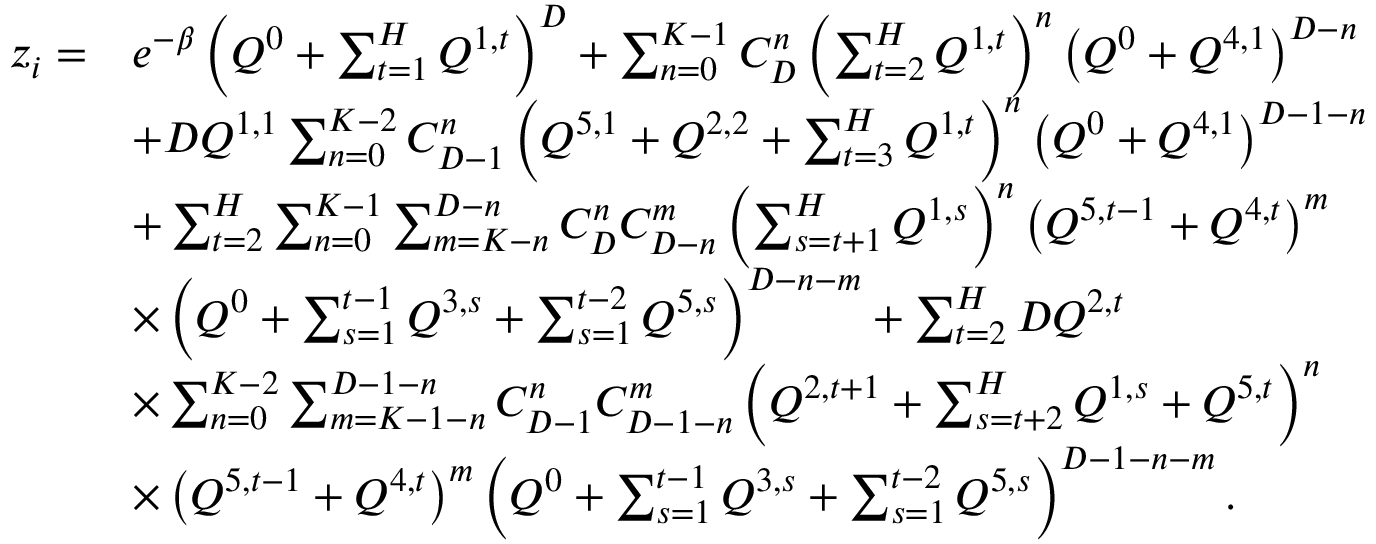<formula> <loc_0><loc_0><loc_500><loc_500>\begin{array} { r l } { z _ { i } = } & { e ^ { - \beta } \left ( Q ^ { 0 } + \sum _ { t = 1 } ^ { H } Q ^ { 1 , t } \right ) ^ { D } + \sum _ { n = 0 } ^ { K - 1 } C _ { D } ^ { n } \left ( \sum _ { t = 2 } ^ { H } Q ^ { 1 , t } \right ) ^ { n } \left ( Q ^ { 0 } + Q ^ { 4 , 1 } \right ) ^ { D - n } } \\ & { + D Q ^ { 1 , 1 } \sum _ { n = 0 } ^ { K - 2 } C _ { D - 1 } ^ { n } \left ( Q ^ { 5 , 1 } + Q ^ { 2 , 2 } + \sum _ { t = 3 } ^ { H } Q ^ { 1 , t } \right ) ^ { n } \left ( Q ^ { 0 } + Q ^ { 4 , 1 } \right ) ^ { D - 1 - n } } \\ & { + \sum _ { t = 2 } ^ { H } \sum _ { n = 0 } ^ { K - 1 } \sum _ { m = K - n } ^ { D - n } C _ { D } ^ { n } C _ { D - n } ^ { m } \left ( \sum _ { s = t + 1 } ^ { H } Q ^ { 1 , s } \right ) ^ { n } \left ( Q ^ { 5 , t - 1 } + Q ^ { 4 , t } \right ) ^ { m } } \\ & { \times \left ( Q ^ { 0 } + \sum _ { s = 1 } ^ { t - 1 } Q ^ { 3 , s } + \sum _ { s = 1 } ^ { t - 2 } Q ^ { 5 , s } \right ) ^ { D - n - m } + \sum _ { t = 2 } ^ { H } D Q ^ { 2 , t } } \\ & { \times \sum _ { n = 0 } ^ { K - 2 } \sum _ { m = K - 1 - n } ^ { D - 1 - n } C _ { D - 1 } ^ { n } C _ { D - 1 - n } ^ { m } \left ( Q ^ { 2 , t + 1 } + \sum _ { s = t + 2 } ^ { H } Q ^ { 1 , s } + Q ^ { 5 , t } \right ) ^ { n } } \\ & { \times \left ( Q ^ { 5 , t - 1 } + Q ^ { 4 , t } \right ) ^ { m } \left ( Q ^ { 0 } + \sum _ { s = 1 } ^ { t - 1 } Q ^ { 3 , s } + \sum _ { s = 1 } ^ { t - 2 } Q ^ { 5 , s } \right ) ^ { D - 1 - n - m } . } \end{array}</formula> 